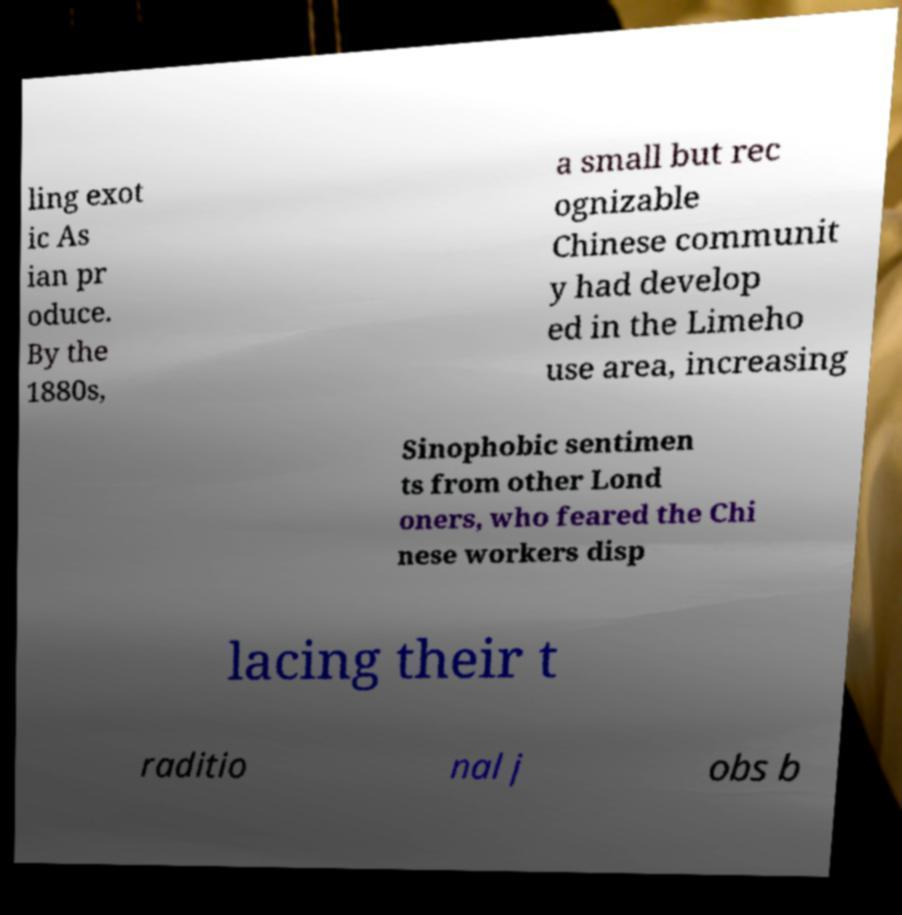There's text embedded in this image that I need extracted. Can you transcribe it verbatim? ling exot ic As ian pr oduce. By the 1880s, a small but rec ognizable Chinese communit y had develop ed in the Limeho use area, increasing Sinophobic sentimen ts from other Lond oners, who feared the Chi nese workers disp lacing their t raditio nal j obs b 